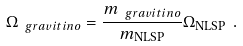<formula> <loc_0><loc_0><loc_500><loc_500>\Omega _ { \ g r a v i t i n o } = \frac { m _ { \ g r a v i t i n o } } { m _ { \text {NLSP} } } \Omega _ { \text {NLSP} } \ .</formula> 